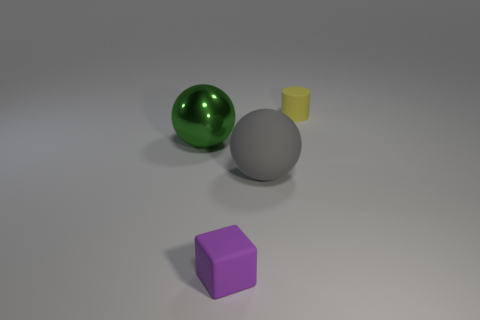There is a small thing in front of the shiny object; does it have the same shape as the big object that is right of the small matte cube? No, the small item in front of the shiny object, which appears to be a small cylinder, does not have the same shape as the larger sphere that is to the right of the small matte cube. 